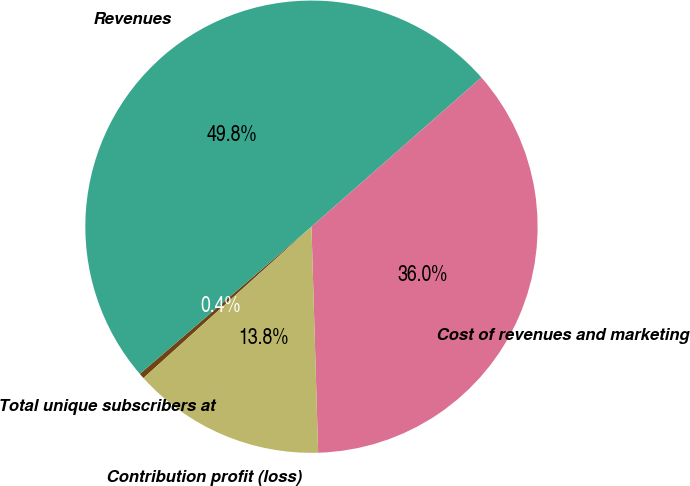Convert chart to OTSL. <chart><loc_0><loc_0><loc_500><loc_500><pie_chart><fcel>Total unique subscribers at<fcel>Revenues<fcel>Cost of revenues and marketing<fcel>Contribution profit (loss)<nl><fcel>0.39%<fcel>49.81%<fcel>36.0%<fcel>13.8%<nl></chart> 